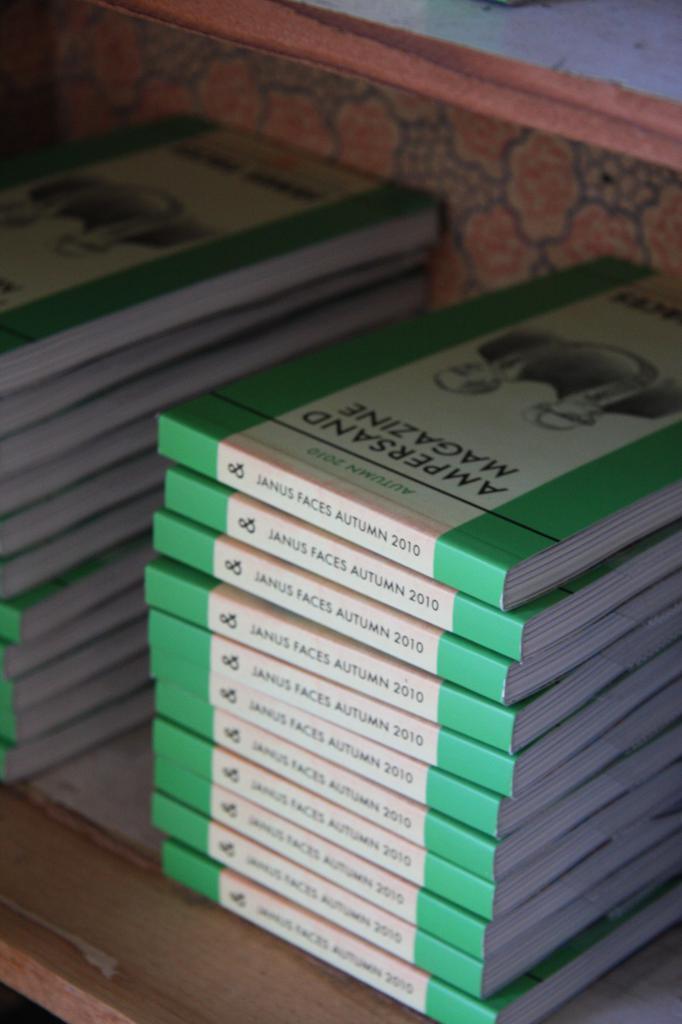Did they really make a magizine for ampersand?
Provide a succinct answer. Yes. What is the year written on these books?
Offer a very short reply. 2010. 